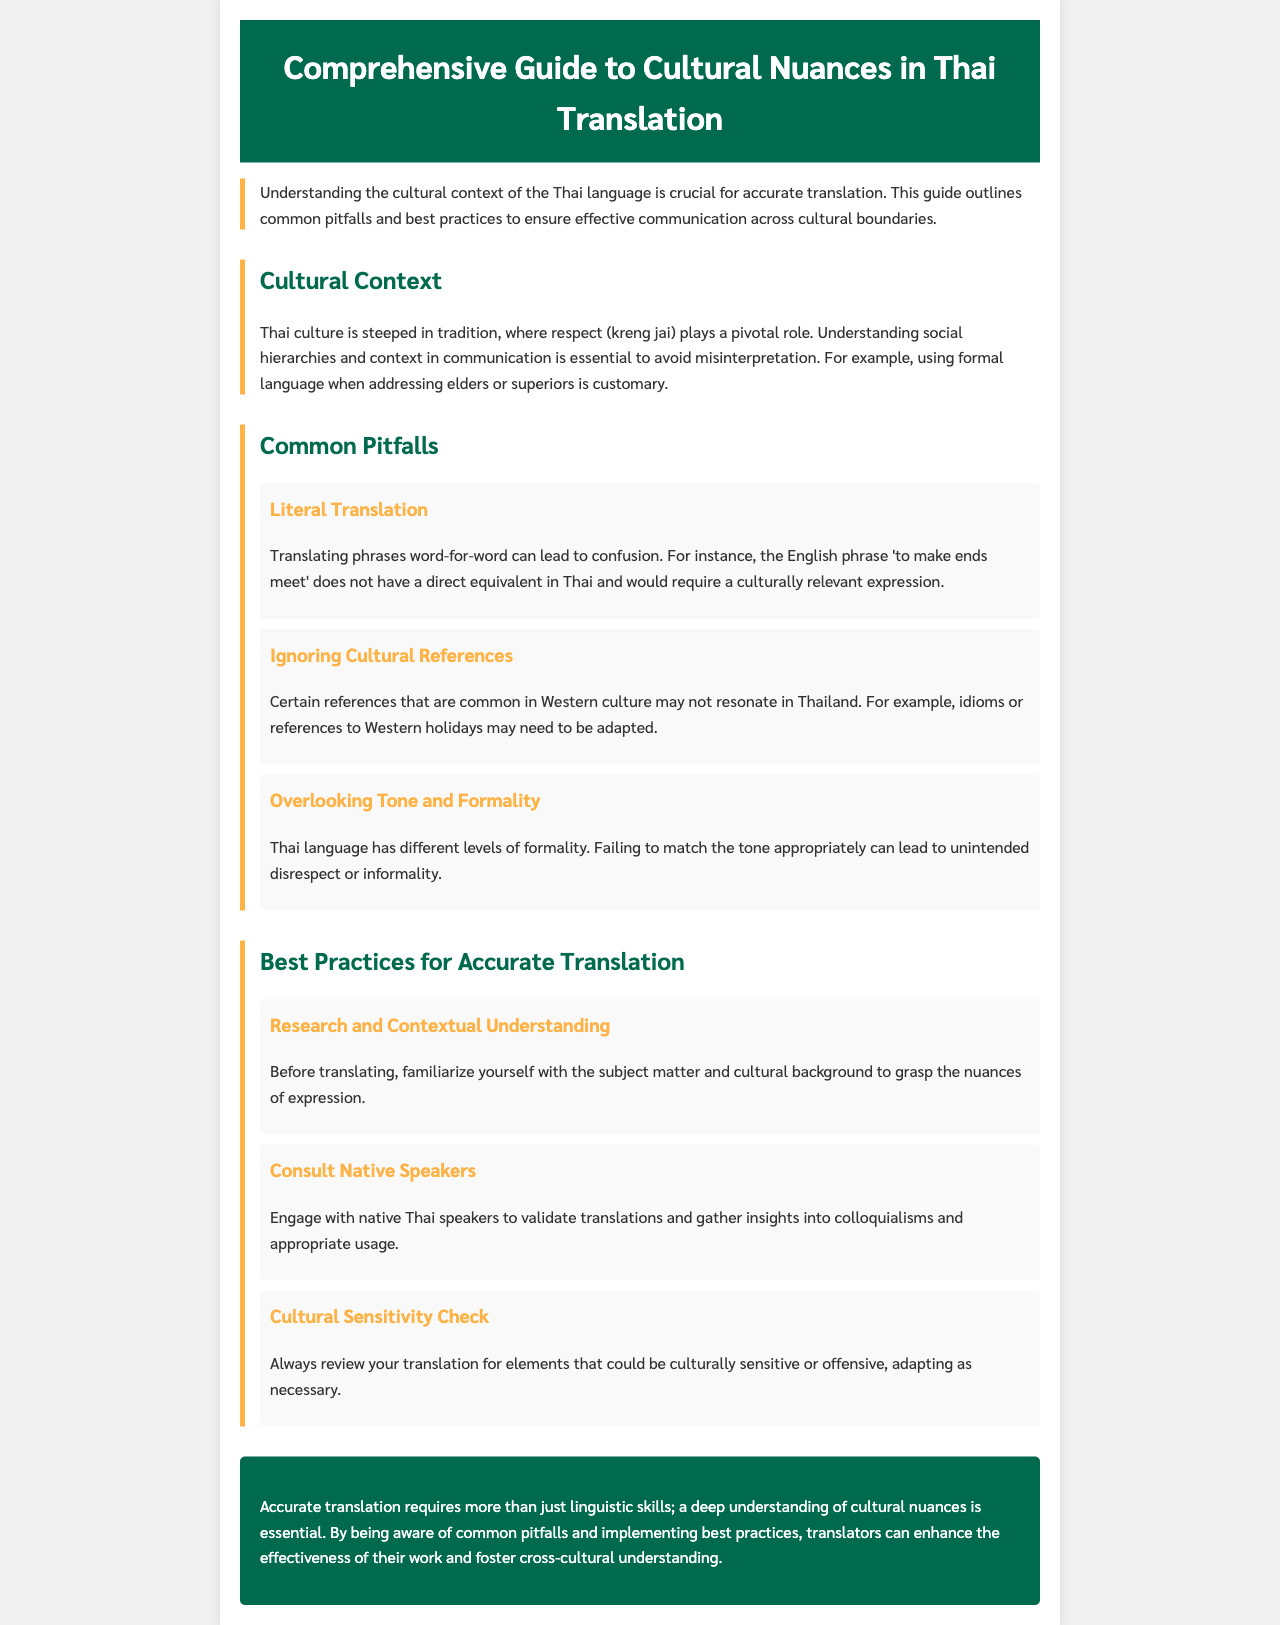What is the title of the guide? The title of the guide is mentioned at the top of the document, clearly indicating the focus on Thai translation.
Answer: Comprehensive Guide to Cultural Nuances in Thai Translation What is a key role in Thai culture? The document highlights the importance of a specific cultural aspect that impacts communication in Thailand.
Answer: Respect (kreng jai) What is one common pitfall in translation? The document lists several pitfalls, with one specifically regarding translation method, impacting clarity.
Answer: Literal Translation What should translators do before translating? According to the best practices section, initial steps are recommended to better understand the subject matter of translations.
Answer: Research and Contextual Understanding Where can translators seek validation for their translations? The guide suggests a specific group that can provide feedback and insights beneficial for translators.
Answer: Native Speakers What is one practice for ensuring cultural sensitivity? The document emphasizes a critical action that translators should perform to avoid offending cultural norms.
Answer: Cultural Sensitivity Check What is an example of a cultural reference to be careful with? The report mentions an example type of reference that may not translate well across cultures, causing misunderstanding.
Answer: Western holidays What does the conclusion emphasize about accurate translation? The final section summarizes an overarching idea crucial for effective translation work.
Answer: Cultural nuances How many common pitfalls are listed? The document provides a specific count of pitfalls that translators should avoid.
Answer: Three 